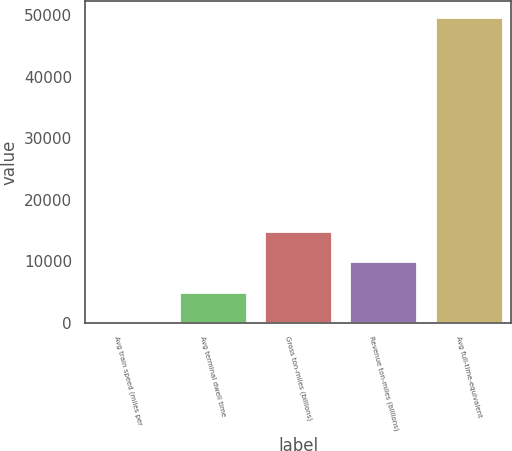<chart> <loc_0><loc_0><loc_500><loc_500><bar_chart><fcel>Avg train speed (miles per<fcel>Avg terminal dwell time<fcel>Gross ton-miles (billions)<fcel>Revenue ton-miles (billions)<fcel>Avg full-time-equivalent<nl><fcel>21.1<fcel>4993.69<fcel>14938.9<fcel>9966.28<fcel>49747<nl></chart> 